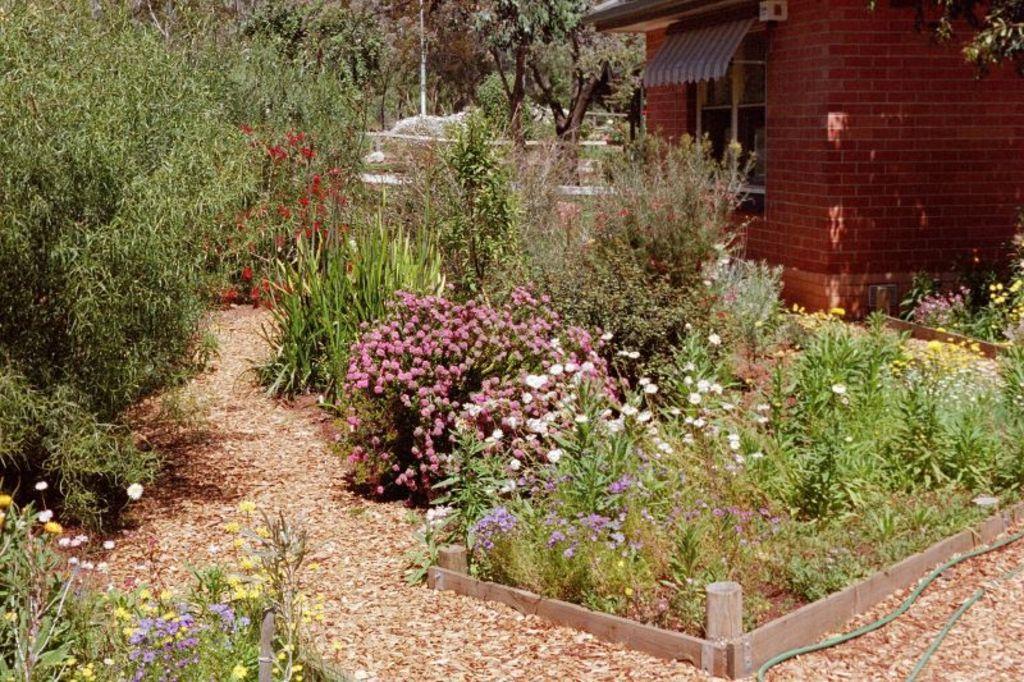Could you give a brief overview of what you see in this image? In this image in front there are plants and flowers. On the right side of the image there is a building. At the bottom of the image there are dried leaves. In the background of the image there are trees. 